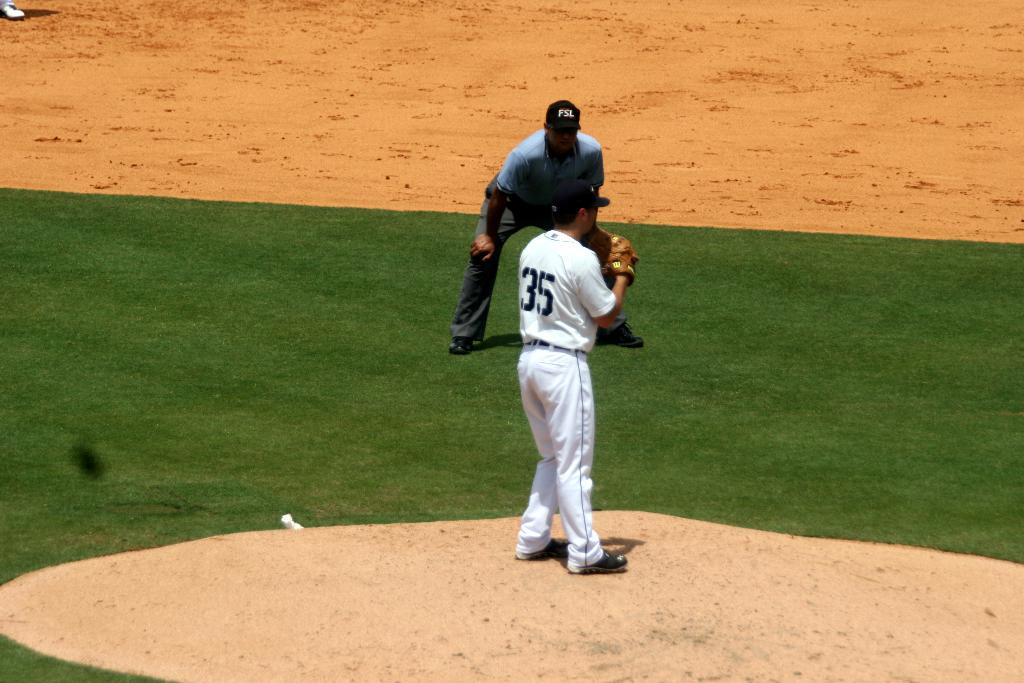<image>
Provide a brief description of the given image. Baseball player number 35 stands on the pitchers mound ready to throw. 